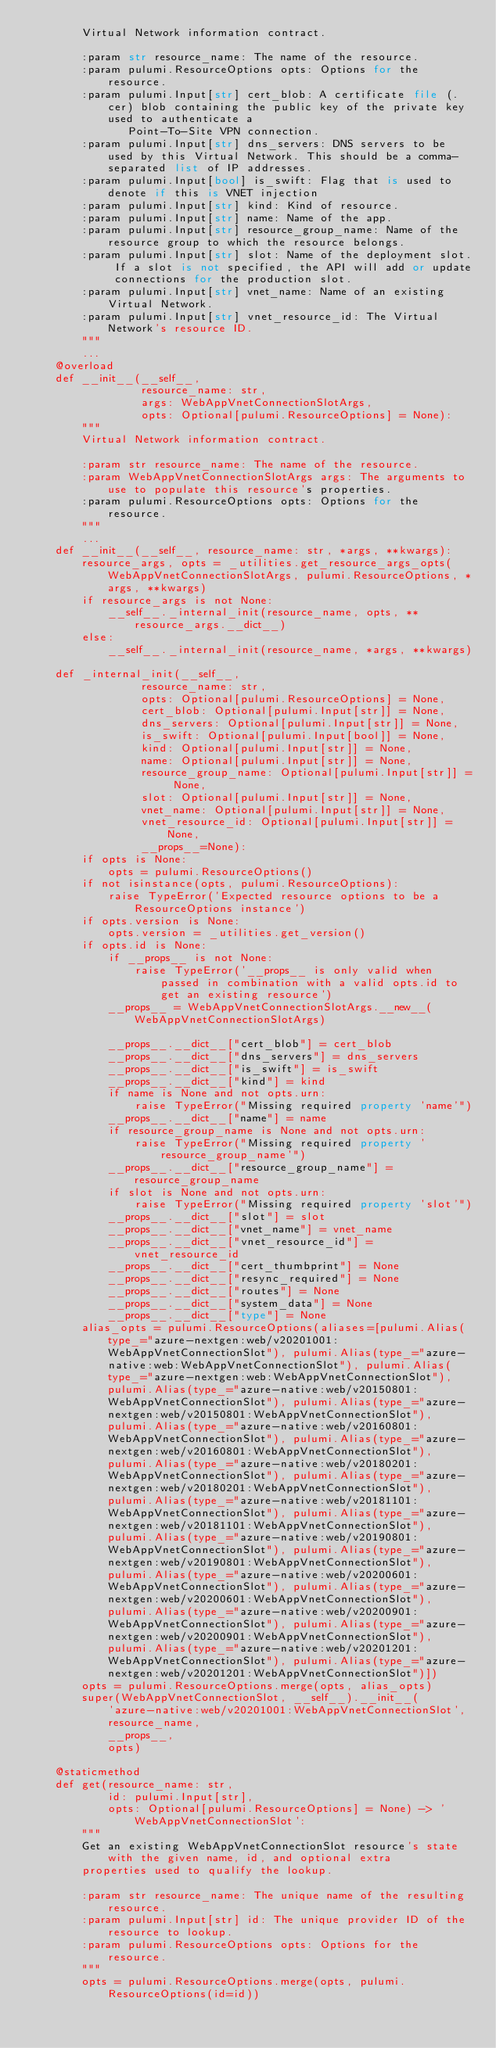Convert code to text. <code><loc_0><loc_0><loc_500><loc_500><_Python_>        Virtual Network information contract.

        :param str resource_name: The name of the resource.
        :param pulumi.ResourceOptions opts: Options for the resource.
        :param pulumi.Input[str] cert_blob: A certificate file (.cer) blob containing the public key of the private key used to authenticate a 
               Point-To-Site VPN connection.
        :param pulumi.Input[str] dns_servers: DNS servers to be used by this Virtual Network. This should be a comma-separated list of IP addresses.
        :param pulumi.Input[bool] is_swift: Flag that is used to denote if this is VNET injection
        :param pulumi.Input[str] kind: Kind of resource.
        :param pulumi.Input[str] name: Name of the app.
        :param pulumi.Input[str] resource_group_name: Name of the resource group to which the resource belongs.
        :param pulumi.Input[str] slot: Name of the deployment slot. If a slot is not specified, the API will add or update connections for the production slot.
        :param pulumi.Input[str] vnet_name: Name of an existing Virtual Network.
        :param pulumi.Input[str] vnet_resource_id: The Virtual Network's resource ID.
        """
        ...
    @overload
    def __init__(__self__,
                 resource_name: str,
                 args: WebAppVnetConnectionSlotArgs,
                 opts: Optional[pulumi.ResourceOptions] = None):
        """
        Virtual Network information contract.

        :param str resource_name: The name of the resource.
        :param WebAppVnetConnectionSlotArgs args: The arguments to use to populate this resource's properties.
        :param pulumi.ResourceOptions opts: Options for the resource.
        """
        ...
    def __init__(__self__, resource_name: str, *args, **kwargs):
        resource_args, opts = _utilities.get_resource_args_opts(WebAppVnetConnectionSlotArgs, pulumi.ResourceOptions, *args, **kwargs)
        if resource_args is not None:
            __self__._internal_init(resource_name, opts, **resource_args.__dict__)
        else:
            __self__._internal_init(resource_name, *args, **kwargs)

    def _internal_init(__self__,
                 resource_name: str,
                 opts: Optional[pulumi.ResourceOptions] = None,
                 cert_blob: Optional[pulumi.Input[str]] = None,
                 dns_servers: Optional[pulumi.Input[str]] = None,
                 is_swift: Optional[pulumi.Input[bool]] = None,
                 kind: Optional[pulumi.Input[str]] = None,
                 name: Optional[pulumi.Input[str]] = None,
                 resource_group_name: Optional[pulumi.Input[str]] = None,
                 slot: Optional[pulumi.Input[str]] = None,
                 vnet_name: Optional[pulumi.Input[str]] = None,
                 vnet_resource_id: Optional[pulumi.Input[str]] = None,
                 __props__=None):
        if opts is None:
            opts = pulumi.ResourceOptions()
        if not isinstance(opts, pulumi.ResourceOptions):
            raise TypeError('Expected resource options to be a ResourceOptions instance')
        if opts.version is None:
            opts.version = _utilities.get_version()
        if opts.id is None:
            if __props__ is not None:
                raise TypeError('__props__ is only valid when passed in combination with a valid opts.id to get an existing resource')
            __props__ = WebAppVnetConnectionSlotArgs.__new__(WebAppVnetConnectionSlotArgs)

            __props__.__dict__["cert_blob"] = cert_blob
            __props__.__dict__["dns_servers"] = dns_servers
            __props__.__dict__["is_swift"] = is_swift
            __props__.__dict__["kind"] = kind
            if name is None and not opts.urn:
                raise TypeError("Missing required property 'name'")
            __props__.__dict__["name"] = name
            if resource_group_name is None and not opts.urn:
                raise TypeError("Missing required property 'resource_group_name'")
            __props__.__dict__["resource_group_name"] = resource_group_name
            if slot is None and not opts.urn:
                raise TypeError("Missing required property 'slot'")
            __props__.__dict__["slot"] = slot
            __props__.__dict__["vnet_name"] = vnet_name
            __props__.__dict__["vnet_resource_id"] = vnet_resource_id
            __props__.__dict__["cert_thumbprint"] = None
            __props__.__dict__["resync_required"] = None
            __props__.__dict__["routes"] = None
            __props__.__dict__["system_data"] = None
            __props__.__dict__["type"] = None
        alias_opts = pulumi.ResourceOptions(aliases=[pulumi.Alias(type_="azure-nextgen:web/v20201001:WebAppVnetConnectionSlot"), pulumi.Alias(type_="azure-native:web:WebAppVnetConnectionSlot"), pulumi.Alias(type_="azure-nextgen:web:WebAppVnetConnectionSlot"), pulumi.Alias(type_="azure-native:web/v20150801:WebAppVnetConnectionSlot"), pulumi.Alias(type_="azure-nextgen:web/v20150801:WebAppVnetConnectionSlot"), pulumi.Alias(type_="azure-native:web/v20160801:WebAppVnetConnectionSlot"), pulumi.Alias(type_="azure-nextgen:web/v20160801:WebAppVnetConnectionSlot"), pulumi.Alias(type_="azure-native:web/v20180201:WebAppVnetConnectionSlot"), pulumi.Alias(type_="azure-nextgen:web/v20180201:WebAppVnetConnectionSlot"), pulumi.Alias(type_="azure-native:web/v20181101:WebAppVnetConnectionSlot"), pulumi.Alias(type_="azure-nextgen:web/v20181101:WebAppVnetConnectionSlot"), pulumi.Alias(type_="azure-native:web/v20190801:WebAppVnetConnectionSlot"), pulumi.Alias(type_="azure-nextgen:web/v20190801:WebAppVnetConnectionSlot"), pulumi.Alias(type_="azure-native:web/v20200601:WebAppVnetConnectionSlot"), pulumi.Alias(type_="azure-nextgen:web/v20200601:WebAppVnetConnectionSlot"), pulumi.Alias(type_="azure-native:web/v20200901:WebAppVnetConnectionSlot"), pulumi.Alias(type_="azure-nextgen:web/v20200901:WebAppVnetConnectionSlot"), pulumi.Alias(type_="azure-native:web/v20201201:WebAppVnetConnectionSlot"), pulumi.Alias(type_="azure-nextgen:web/v20201201:WebAppVnetConnectionSlot")])
        opts = pulumi.ResourceOptions.merge(opts, alias_opts)
        super(WebAppVnetConnectionSlot, __self__).__init__(
            'azure-native:web/v20201001:WebAppVnetConnectionSlot',
            resource_name,
            __props__,
            opts)

    @staticmethod
    def get(resource_name: str,
            id: pulumi.Input[str],
            opts: Optional[pulumi.ResourceOptions] = None) -> 'WebAppVnetConnectionSlot':
        """
        Get an existing WebAppVnetConnectionSlot resource's state with the given name, id, and optional extra
        properties used to qualify the lookup.

        :param str resource_name: The unique name of the resulting resource.
        :param pulumi.Input[str] id: The unique provider ID of the resource to lookup.
        :param pulumi.ResourceOptions opts: Options for the resource.
        """
        opts = pulumi.ResourceOptions.merge(opts, pulumi.ResourceOptions(id=id))
</code> 